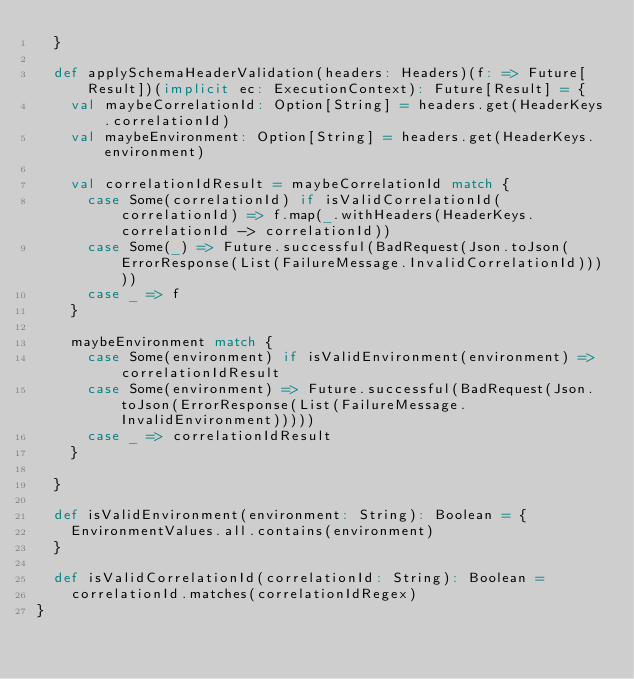Convert code to text. <code><loc_0><loc_0><loc_500><loc_500><_Scala_>  }

  def applySchemaHeaderValidation(headers: Headers)(f: => Future[Result])(implicit ec: ExecutionContext): Future[Result] = {
    val maybeCorrelationId: Option[String] = headers.get(HeaderKeys.correlationId)
    val maybeEnvironment: Option[String] = headers.get(HeaderKeys.environment)

    val correlationIdResult = maybeCorrelationId match {
      case Some(correlationId) if isValidCorrelationId(correlationId) => f.map(_.withHeaders(HeaderKeys.correlationId -> correlationId))
      case Some(_) => Future.successful(BadRequest(Json.toJson(ErrorResponse(List(FailureMessage.InvalidCorrelationId)))))
      case _ => f
    }

    maybeEnvironment match {
      case Some(environment) if isValidEnvironment(environment) => correlationIdResult
      case Some(environment) => Future.successful(BadRequest(Json.toJson(ErrorResponse(List(FailureMessage.InvalidEnvironment)))))
      case _ => correlationIdResult
    }

  }

  def isValidEnvironment(environment: String): Boolean = {
    EnvironmentValues.all.contains(environment)
  }
  
  def isValidCorrelationId(correlationId: String): Boolean = 
    correlationId.matches(correlationIdRegex)
}</code> 